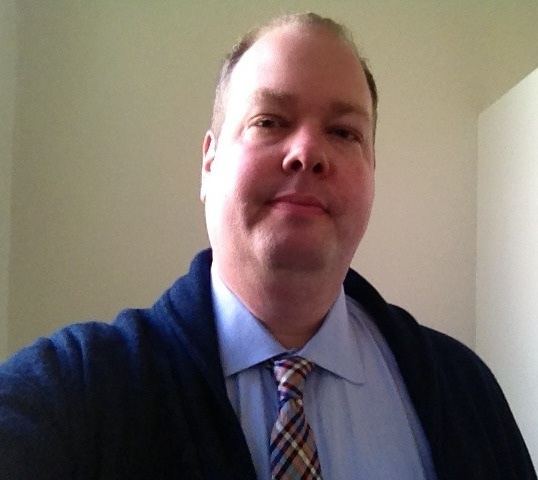Describe the objects in this image and their specific colors. I can see people in gray, black, and maroon tones and tie in gray, black, maroon, and navy tones in this image. 